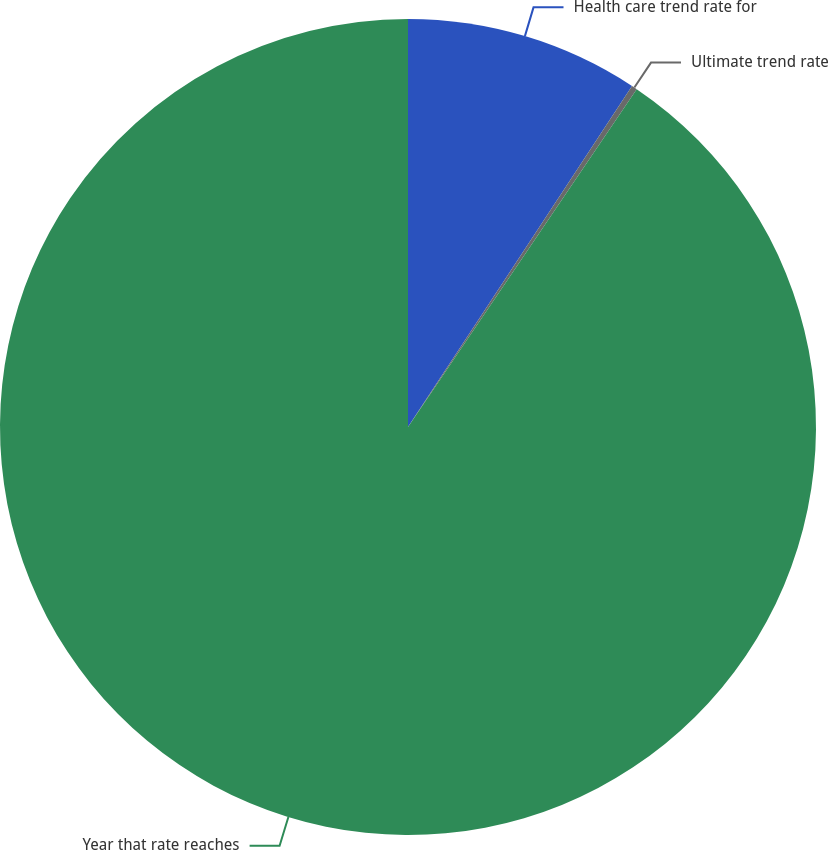<chart> <loc_0><loc_0><loc_500><loc_500><pie_chart><fcel>Health care trend rate for<fcel>Ultimate trend rate<fcel>Year that rate reaches<nl><fcel>9.25%<fcel>0.22%<fcel>90.52%<nl></chart> 